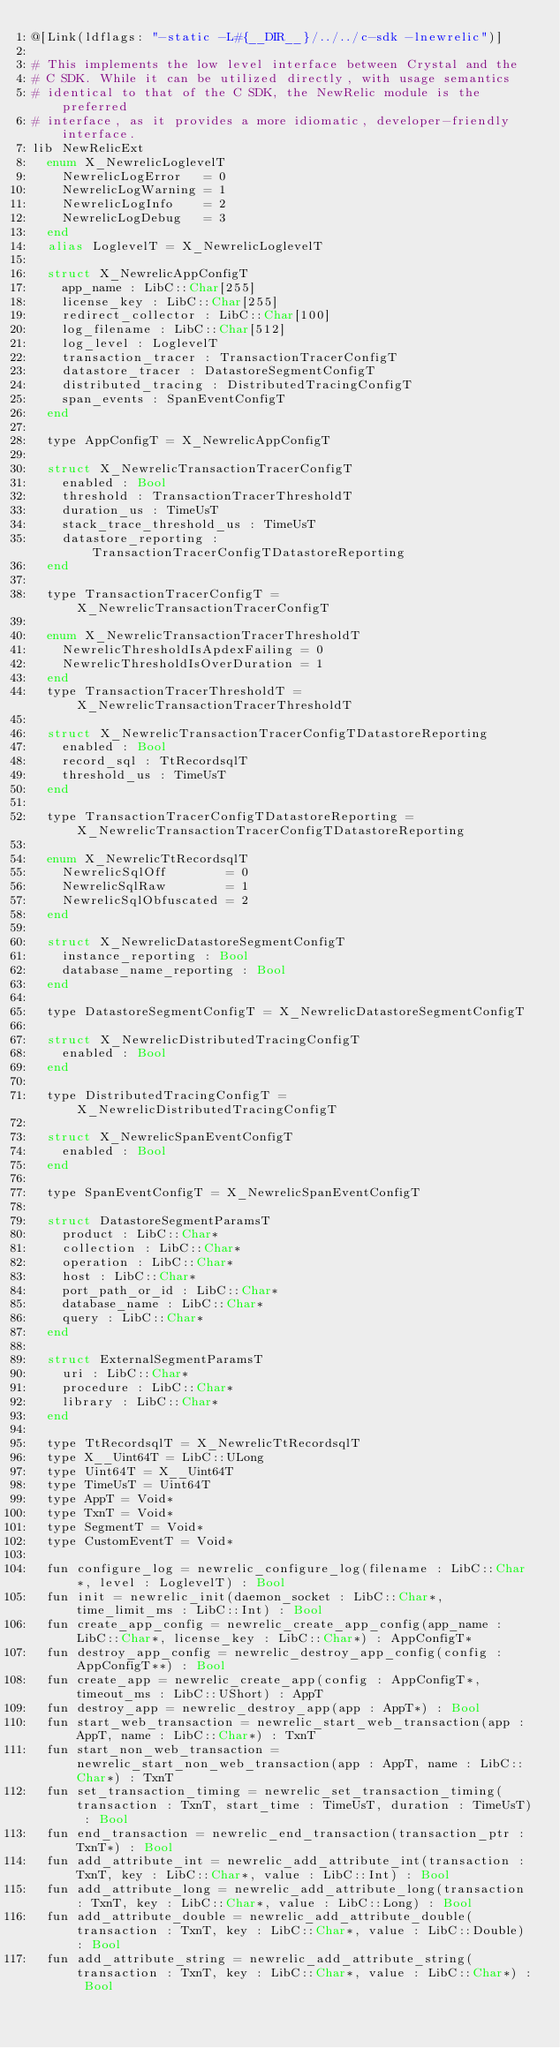<code> <loc_0><loc_0><loc_500><loc_500><_Crystal_>@[Link(ldflags: "-static -L#{__DIR__}/../../c-sdk -lnewrelic")]

# This implements the low level interface between Crystal and the
# C SDK. While it can be utilized directly, with usage semantics
# identical to that of the C SDK, the NewRelic module is the preferred
# interface, as it provides a more idiomatic, developer-friendly interface.
lib NewRelicExt
  enum X_NewrelicLoglevelT
    NewrelicLogError   = 0
    NewrelicLogWarning = 1
    NewrelicLogInfo    = 2
    NewrelicLogDebug   = 3
  end
  alias LoglevelT = X_NewrelicLoglevelT

  struct X_NewrelicAppConfigT
    app_name : LibC::Char[255]
    license_key : LibC::Char[255]
    redirect_collector : LibC::Char[100]
    log_filename : LibC::Char[512]
    log_level : LoglevelT
    transaction_tracer : TransactionTracerConfigT
    datastore_tracer : DatastoreSegmentConfigT
    distributed_tracing : DistributedTracingConfigT
    span_events : SpanEventConfigT
  end

  type AppConfigT = X_NewrelicAppConfigT

  struct X_NewrelicTransactionTracerConfigT
    enabled : Bool
    threshold : TransactionTracerThresholdT
    duration_us : TimeUsT
    stack_trace_threshold_us : TimeUsT
    datastore_reporting : TransactionTracerConfigTDatastoreReporting
  end

  type TransactionTracerConfigT = X_NewrelicTransactionTracerConfigT

  enum X_NewrelicTransactionTracerThresholdT
    NewrelicThresholdIsApdexFailing = 0
    NewrelicThresholdIsOverDuration = 1
  end
  type TransactionTracerThresholdT = X_NewrelicTransactionTracerThresholdT

  struct X_NewrelicTransactionTracerConfigTDatastoreReporting
    enabled : Bool
    record_sql : TtRecordsqlT
    threshold_us : TimeUsT
  end

  type TransactionTracerConfigTDatastoreReporting = X_NewrelicTransactionTracerConfigTDatastoreReporting

  enum X_NewrelicTtRecordsqlT
    NewrelicSqlOff        = 0
    NewrelicSqlRaw        = 1
    NewrelicSqlObfuscated = 2
  end

  struct X_NewrelicDatastoreSegmentConfigT
    instance_reporting : Bool
    database_name_reporting : Bool
  end

  type DatastoreSegmentConfigT = X_NewrelicDatastoreSegmentConfigT

  struct X_NewrelicDistributedTracingConfigT
    enabled : Bool
  end

  type DistributedTracingConfigT = X_NewrelicDistributedTracingConfigT

  struct X_NewrelicSpanEventConfigT
    enabled : Bool
  end

  type SpanEventConfigT = X_NewrelicSpanEventConfigT

  struct DatastoreSegmentParamsT
    product : LibC::Char*
    collection : LibC::Char*
    operation : LibC::Char*
    host : LibC::Char*
    port_path_or_id : LibC::Char*
    database_name : LibC::Char*
    query : LibC::Char*
  end

  struct ExternalSegmentParamsT
    uri : LibC::Char*
    procedure : LibC::Char*
    library : LibC::Char*
  end

  type TtRecordsqlT = X_NewrelicTtRecordsqlT
  type X__Uint64T = LibC::ULong
  type Uint64T = X__Uint64T
  type TimeUsT = Uint64T
  type AppT = Void*
  type TxnT = Void*
  type SegmentT = Void*
  type CustomEventT = Void*

  fun configure_log = newrelic_configure_log(filename : LibC::Char*, level : LoglevelT) : Bool
  fun init = newrelic_init(daemon_socket : LibC::Char*, time_limit_ms : LibC::Int) : Bool
  fun create_app_config = newrelic_create_app_config(app_name : LibC::Char*, license_key : LibC::Char*) : AppConfigT*
  fun destroy_app_config = newrelic_destroy_app_config(config : AppConfigT**) : Bool
  fun create_app = newrelic_create_app(config : AppConfigT*, timeout_ms : LibC::UShort) : AppT
  fun destroy_app = newrelic_destroy_app(app : AppT*) : Bool
  fun start_web_transaction = newrelic_start_web_transaction(app : AppT, name : LibC::Char*) : TxnT
  fun start_non_web_transaction = newrelic_start_non_web_transaction(app : AppT, name : LibC::Char*) : TxnT
  fun set_transaction_timing = newrelic_set_transaction_timing(transaction : TxnT, start_time : TimeUsT, duration : TimeUsT) : Bool
  fun end_transaction = newrelic_end_transaction(transaction_ptr : TxnT*) : Bool
  fun add_attribute_int = newrelic_add_attribute_int(transaction : TxnT, key : LibC::Char*, value : LibC::Int) : Bool
  fun add_attribute_long = newrelic_add_attribute_long(transaction : TxnT, key : LibC::Char*, value : LibC::Long) : Bool
  fun add_attribute_double = newrelic_add_attribute_double(transaction : TxnT, key : LibC::Char*, value : LibC::Double) : Bool
  fun add_attribute_string = newrelic_add_attribute_string(transaction : TxnT, key : LibC::Char*, value : LibC::Char*) : Bool</code> 